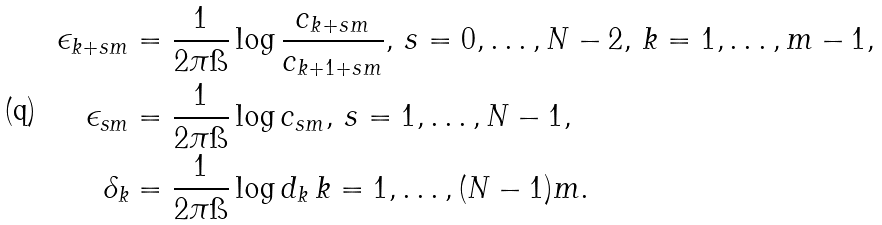<formula> <loc_0><loc_0><loc_500><loc_500>\epsilon _ { k + s m } & = \frac { 1 } { 2 \pi \i } \log \frac { c _ { k + s m } } { c _ { k + 1 + s m } } , \, s = 0 , \dots , N - 2 , \, k = 1 , \dots , m - 1 , \\ \epsilon _ { s m } & = \frac { 1 } { 2 \pi \i } \log c _ { s m } , \, s = 1 , \dots , N - 1 , \\ \delta _ { k } & = \frac { 1 } { 2 \pi \i } \log d _ { k } \, k = 1 , \dots , ( N - 1 ) m .</formula> 